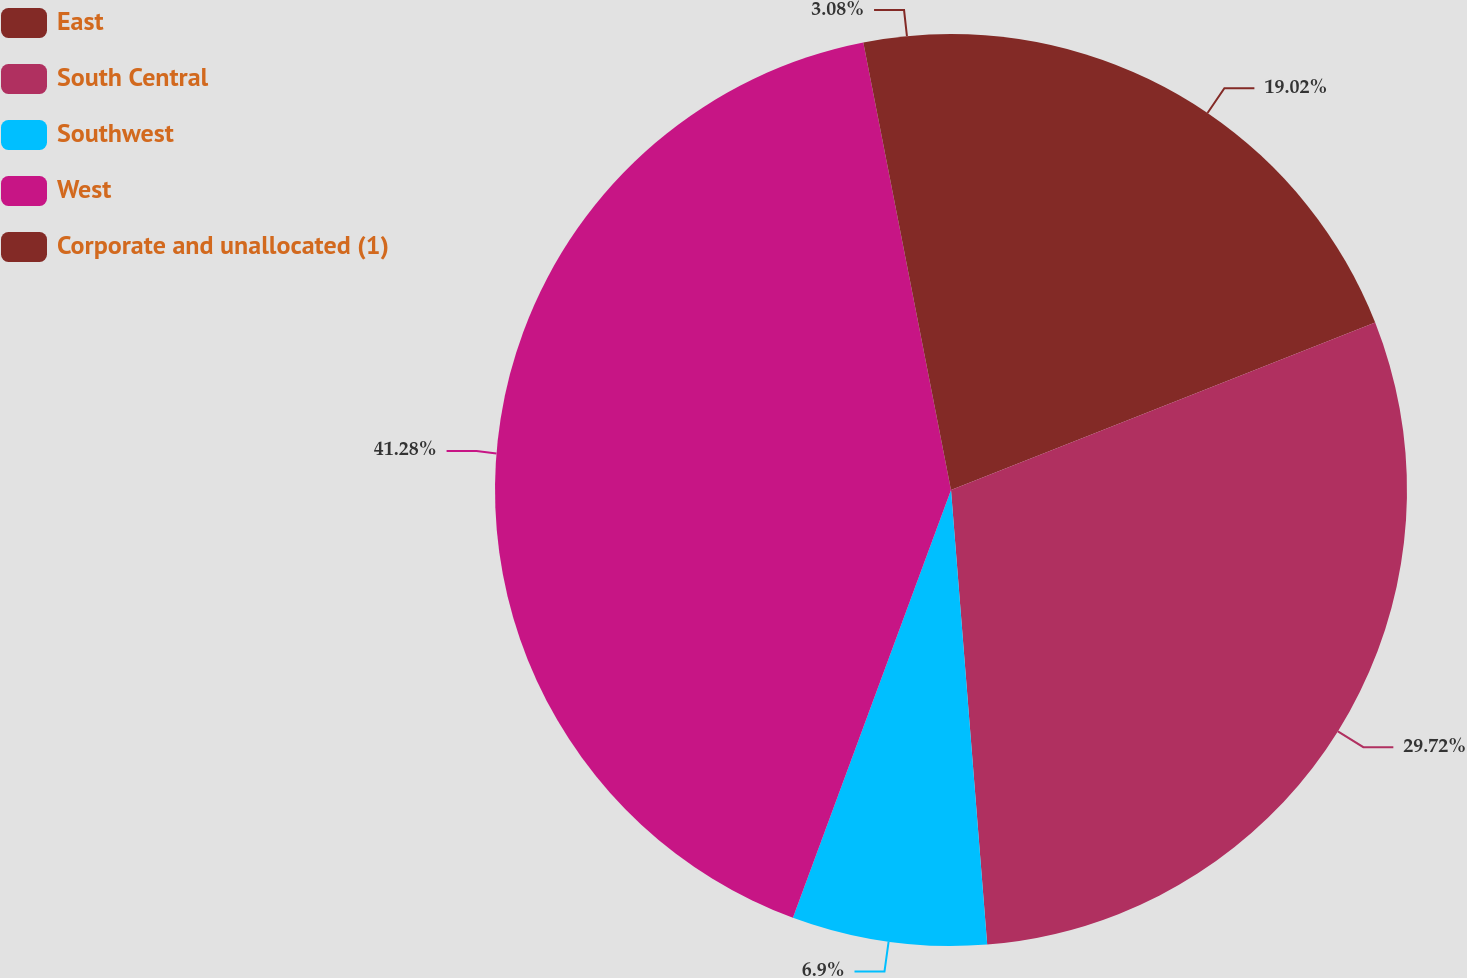<chart> <loc_0><loc_0><loc_500><loc_500><pie_chart><fcel>East<fcel>South Central<fcel>Southwest<fcel>West<fcel>Corporate and unallocated (1)<nl><fcel>19.02%<fcel>29.72%<fcel>6.9%<fcel>41.29%<fcel>3.08%<nl></chart> 